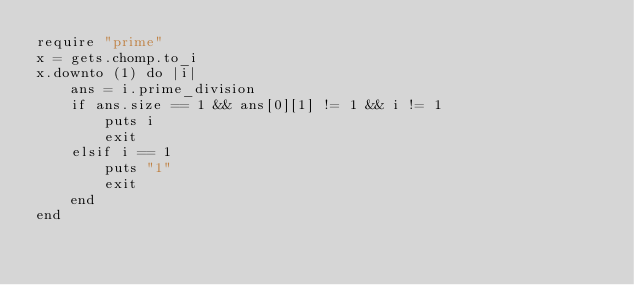<code> <loc_0><loc_0><loc_500><loc_500><_Ruby_>require "prime"
x = gets.chomp.to_i
x.downto (1) do |i|
    ans = i.prime_division
    if ans.size == 1 && ans[0][1] != 1 && i != 1
        puts i
        exit
    elsif i == 1
        puts "1"
        exit
    end
end
</code> 